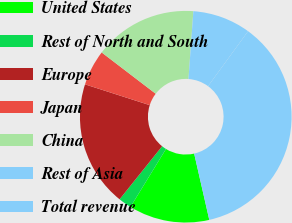Convert chart to OTSL. <chart><loc_0><loc_0><loc_500><loc_500><pie_chart><fcel>United States<fcel>Rest of North and South<fcel>Europe<fcel>Japan<fcel>China<fcel>Rest of Asia<fcel>Total revenue<nl><fcel>12.32%<fcel>2.0%<fcel>19.2%<fcel>5.44%<fcel>15.76%<fcel>8.88%<fcel>36.41%<nl></chart> 